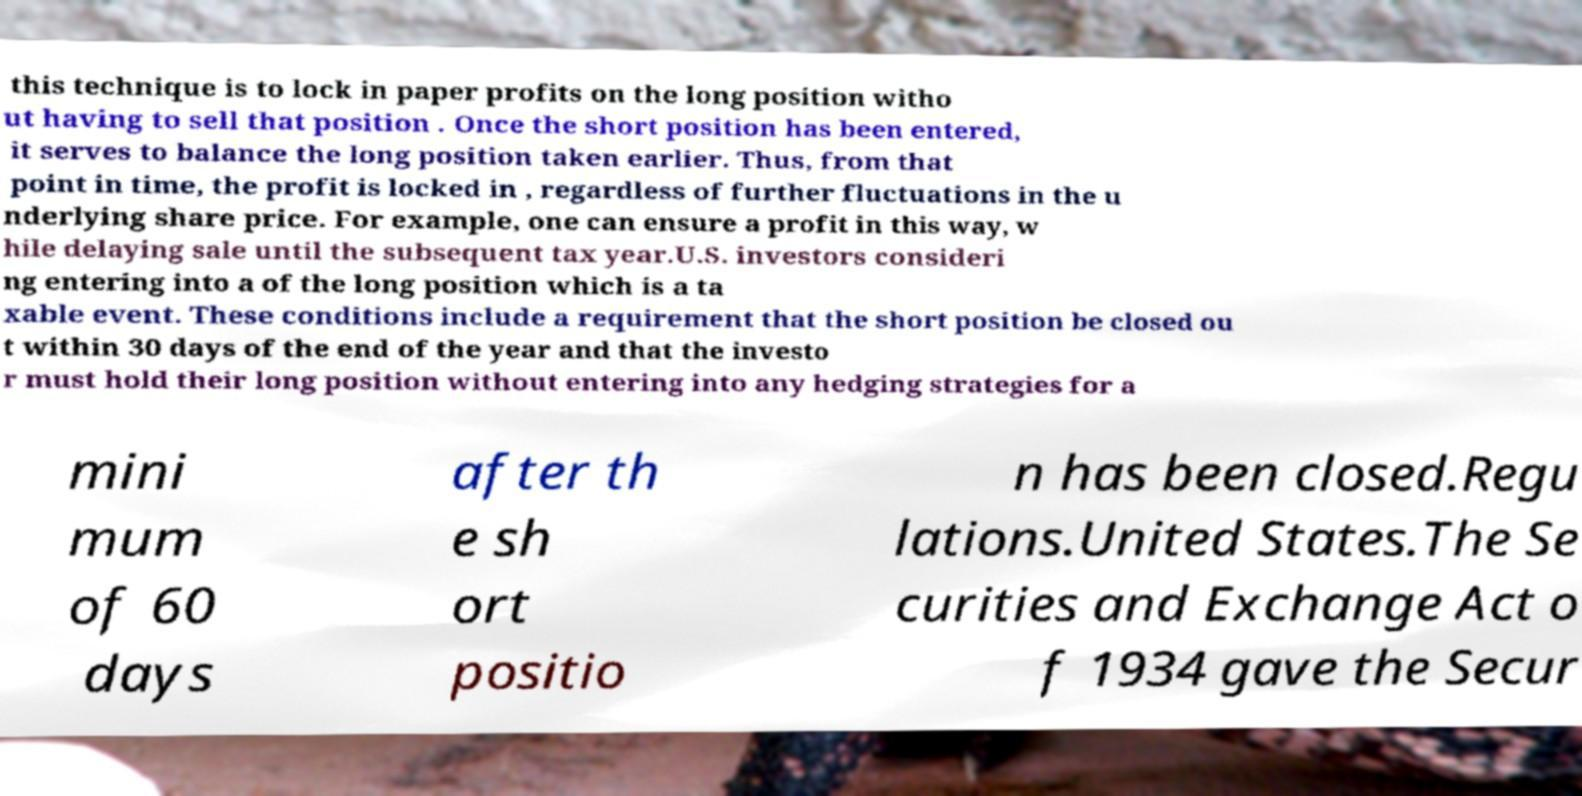For documentation purposes, I need the text within this image transcribed. Could you provide that? this technique is to lock in paper profits on the long position witho ut having to sell that position . Once the short position has been entered, it serves to balance the long position taken earlier. Thus, from that point in time, the profit is locked in , regardless of further fluctuations in the u nderlying share price. For example, one can ensure a profit in this way, w hile delaying sale until the subsequent tax year.U.S. investors consideri ng entering into a of the long position which is a ta xable event. These conditions include a requirement that the short position be closed ou t within 30 days of the end of the year and that the investo r must hold their long position without entering into any hedging strategies for a mini mum of 60 days after th e sh ort positio n has been closed.Regu lations.United States.The Se curities and Exchange Act o f 1934 gave the Secur 